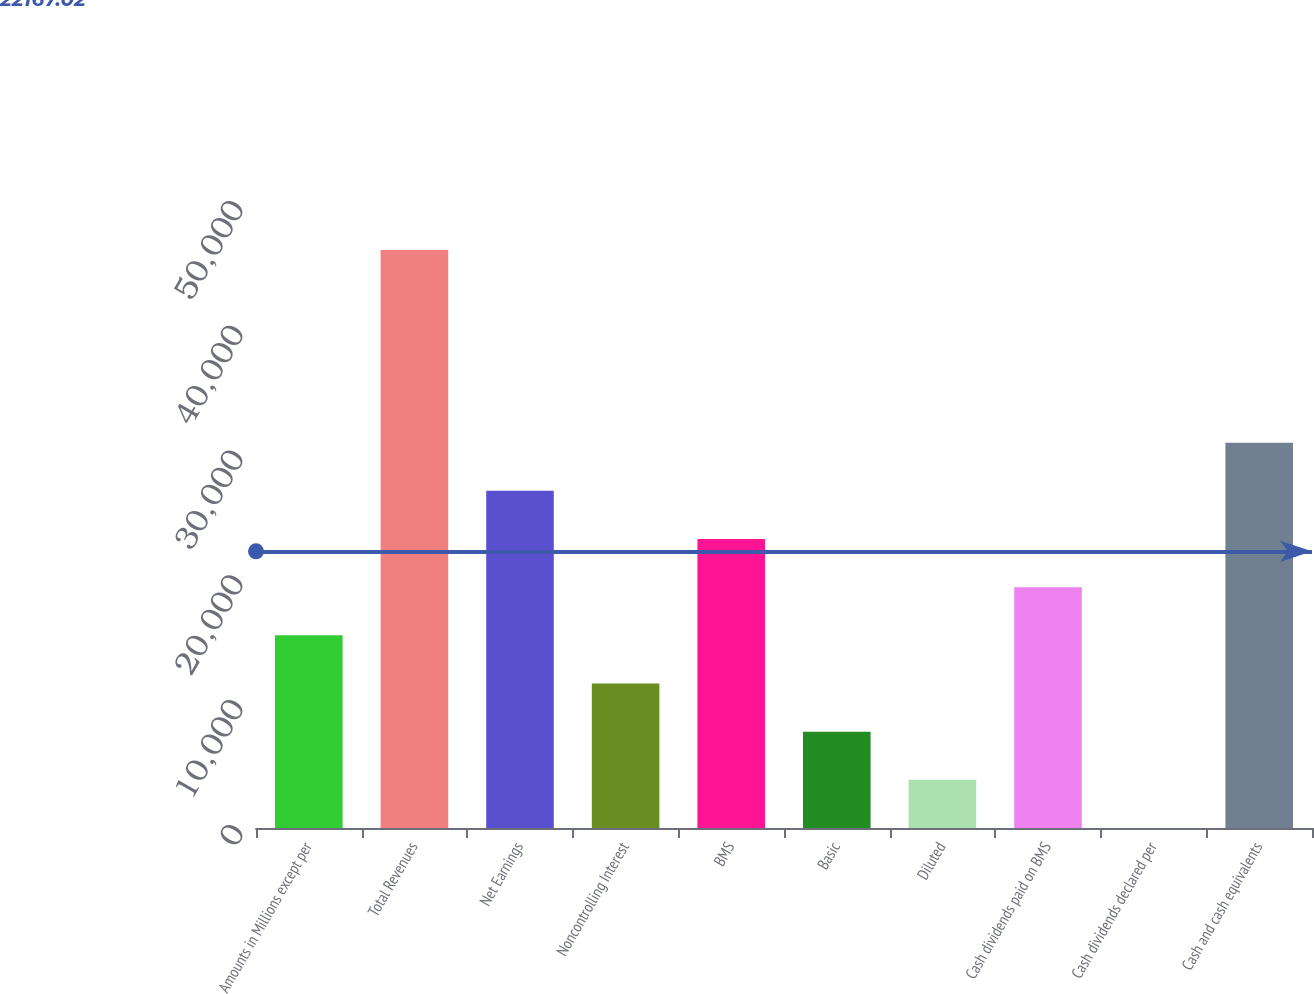<chart> <loc_0><loc_0><loc_500><loc_500><bar_chart><fcel>Amounts in Millions except per<fcel>Total Revenues<fcel>Net Earnings<fcel>Noncontrolling Interest<fcel>BMS<fcel>Basic<fcel>Diluted<fcel>Cash dividends paid on BMS<fcel>Cash dividends declared per<fcel>Cash and cash equivalents<nl><fcel>15437.6<fcel>46310.1<fcel>27014.8<fcel>11578.6<fcel>23155.8<fcel>7719.53<fcel>3860.47<fcel>19296.7<fcel>1.41<fcel>30873.9<nl></chart> 